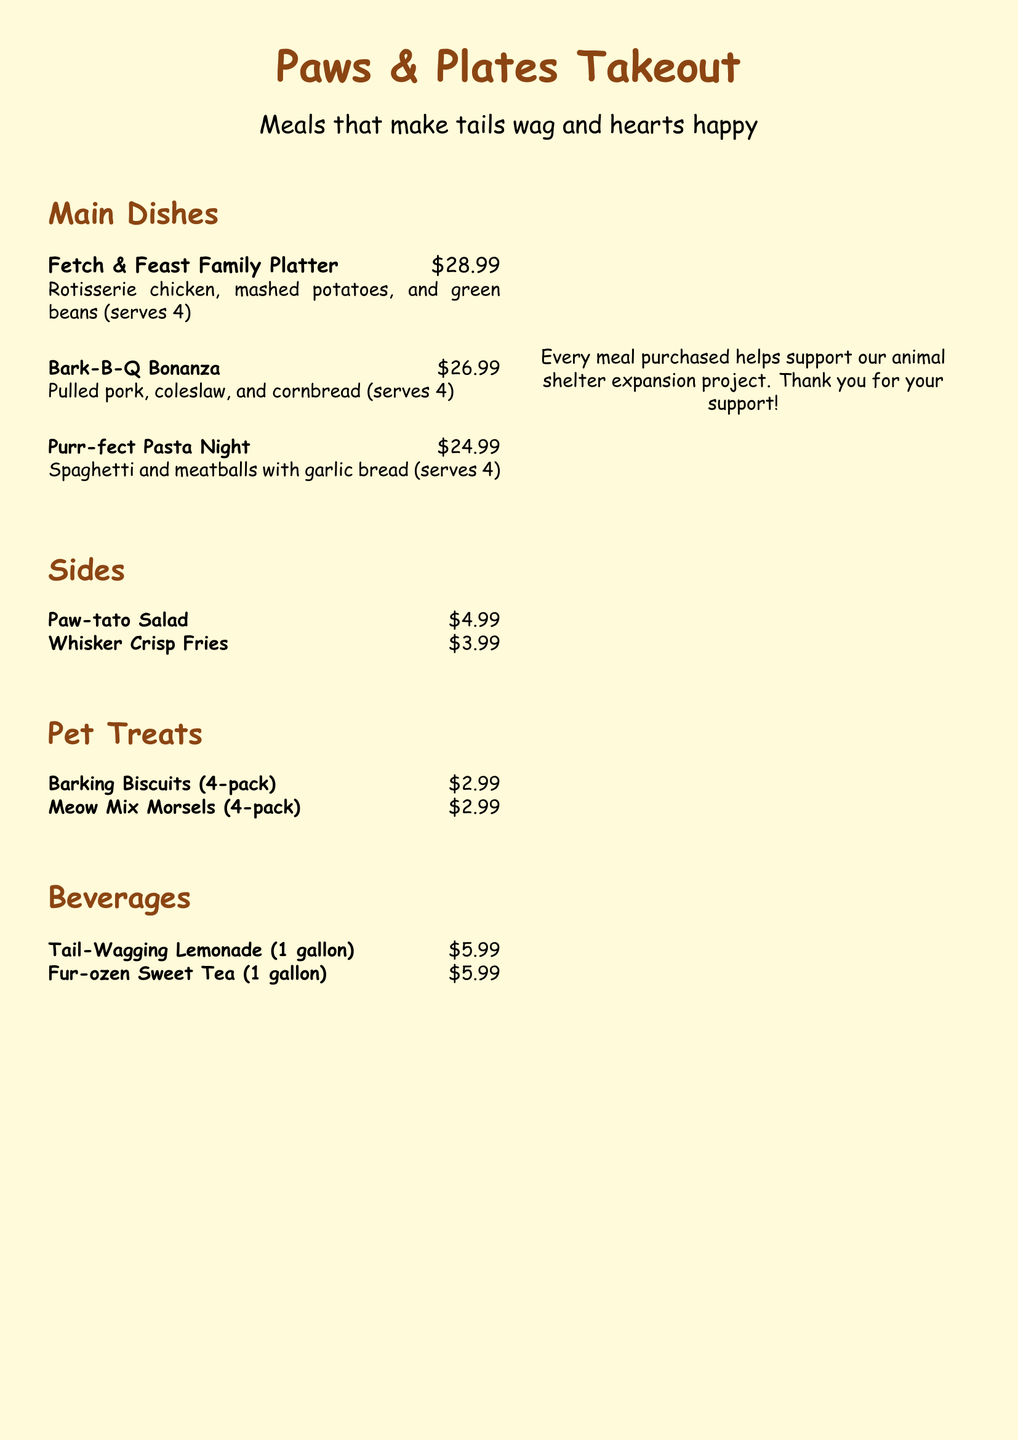What is the price of the Fetch & Feast Family Platter? The price is listed next to the dish name in the menu.
Answer: $28.99 What items are included in the Bark-B-Q Bonanza? The menu describes the contents of each dish under its name.
Answer: Pulled pork, coleslaw, and cornbread How many servings does the Purr-fect Pasta Night provide? The menu specifies the number of servings for each dish.
Answer: 4 What is the price for a 4-pack of Barking Biscuits? The price is shown next to the pet treat item in the menu.
Answer: $2.99 What type of beverages are offered? The menu lists all beverage options under the Beverages section.
Answer: Tail-Wagging Lemonade, Fur-ozen Sweet Tea Which color is the background of the menu? The background color can be identified from the document's specifications.
Answer: Paw yellow How many main dishes are listed on the menu? The number can be counted by looking at the Main Dishes section.
Answer: 3 What is the purpose of the QR code mentioned in the document? The purpose is provided in the descriptive text near the QR code.
Answer: Help us expand our shelter What meal helps support the animal shelter expansion project? The text indicates that purchasing any meal contributes to the shelter's project.
Answer: Every meal purchased 